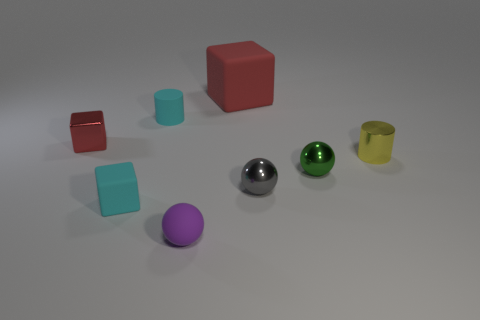Is there anything else that has the same size as the red matte thing?
Offer a very short reply. No. There is a object that is the same color as the small shiny cube; what is its size?
Offer a very short reply. Large. Is the number of cyan rubber objects behind the small cyan cube greater than the number of red metallic cylinders?
Provide a succinct answer. Yes. The metallic block that is the same size as the purple rubber ball is what color?
Your answer should be very brief. Red. What number of objects are cylinders right of the purple thing or tiny purple objects?
Provide a succinct answer. 2. What shape is the object that is the same color as the big cube?
Give a very brief answer. Cube. The cylinder right of the red block that is on the right side of the purple sphere is made of what material?
Your answer should be compact. Metal. Are there any cyan cubes made of the same material as the big object?
Provide a succinct answer. Yes. Is there a cyan rubber block that is left of the tiny cylinder left of the green thing?
Your answer should be compact. Yes. There is a block right of the matte cylinder; what is it made of?
Keep it short and to the point. Rubber. 